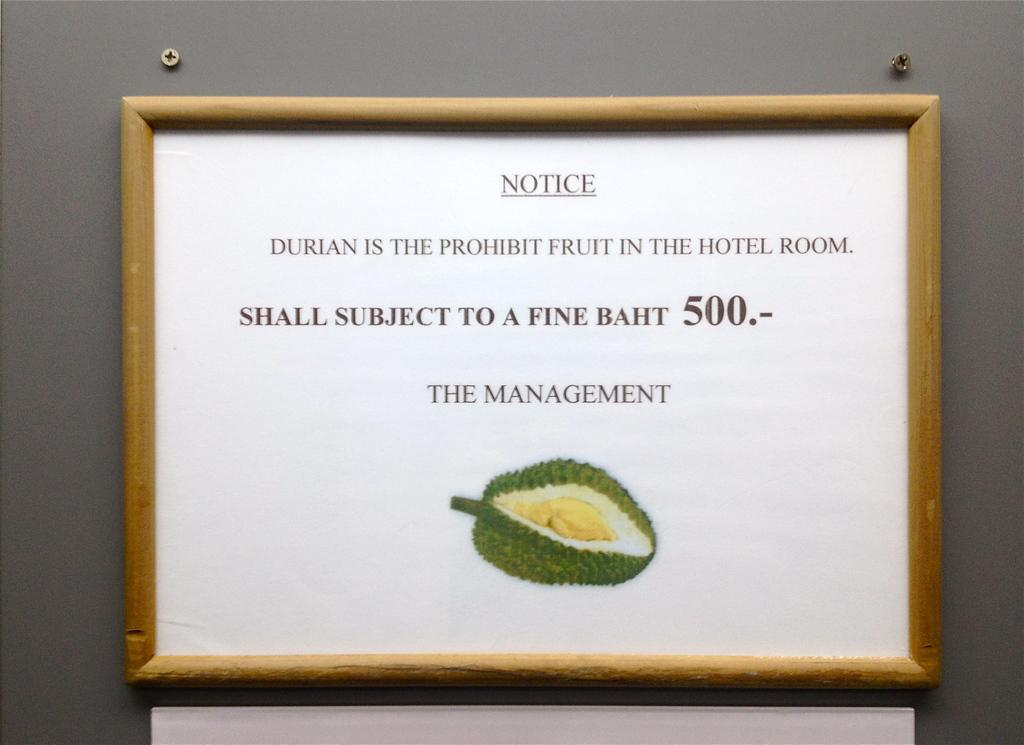What is the main object on the wall in the image? There is a notice board in the image. What color is the wall behind the notice board? The wall behind the notice board is gray. What can be found on the notice board? There is information on the notice board. Is there any specific image on the notice board? Yes, there is a picture of a jackfruit in the image. What time of day is it in the image? The time of day is not mentioned or depicted in the image. Can you tell me what the air quality is like in the image? There is no information about the air quality in the image. 